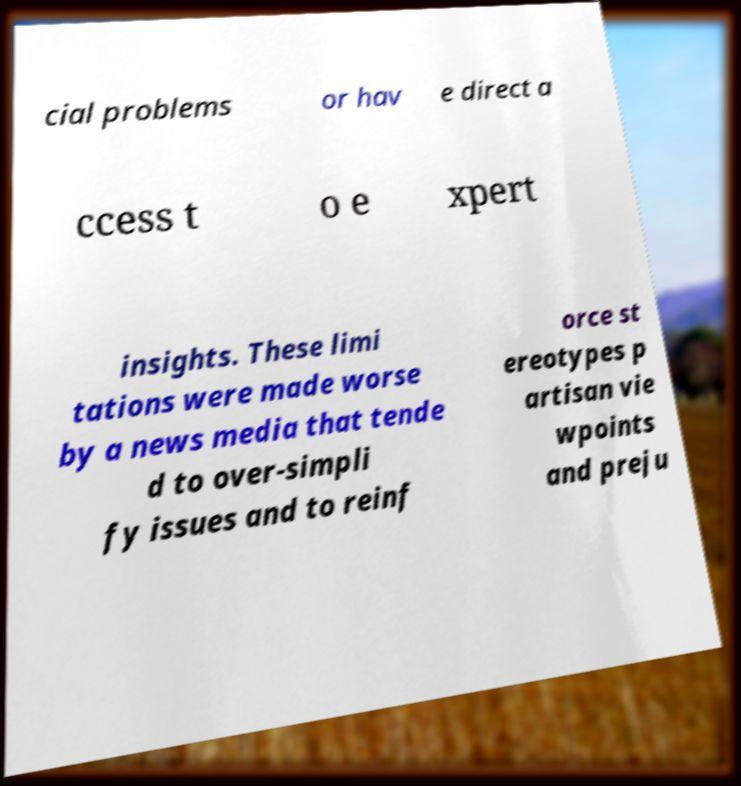Can you read and provide the text displayed in the image?This photo seems to have some interesting text. Can you extract and type it out for me? cial problems or hav e direct a ccess t o e xpert insights. These limi tations were made worse by a news media that tende d to over-simpli fy issues and to reinf orce st ereotypes p artisan vie wpoints and preju 